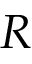<formula> <loc_0><loc_0><loc_500><loc_500>R</formula> 